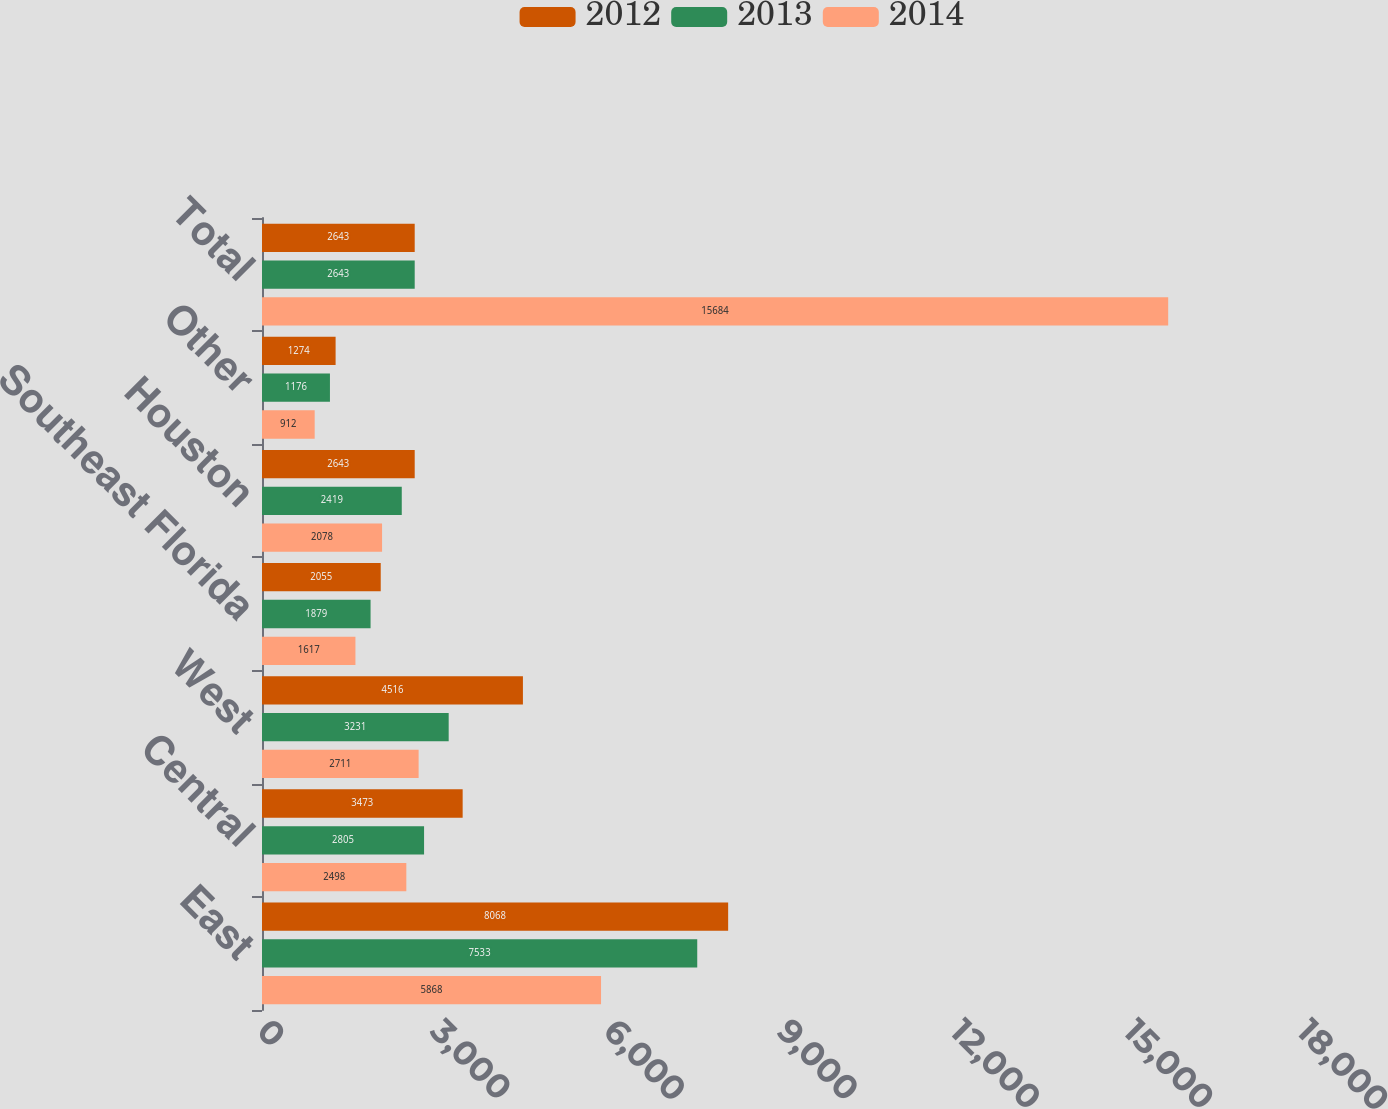<chart> <loc_0><loc_0><loc_500><loc_500><stacked_bar_chart><ecel><fcel>East<fcel>Central<fcel>West<fcel>Southeast Florida<fcel>Houston<fcel>Other<fcel>Total<nl><fcel>2012<fcel>8068<fcel>3473<fcel>4516<fcel>2055<fcel>2643<fcel>1274<fcel>2643<nl><fcel>2013<fcel>7533<fcel>2805<fcel>3231<fcel>1879<fcel>2419<fcel>1176<fcel>2643<nl><fcel>2014<fcel>5868<fcel>2498<fcel>2711<fcel>1617<fcel>2078<fcel>912<fcel>15684<nl></chart> 